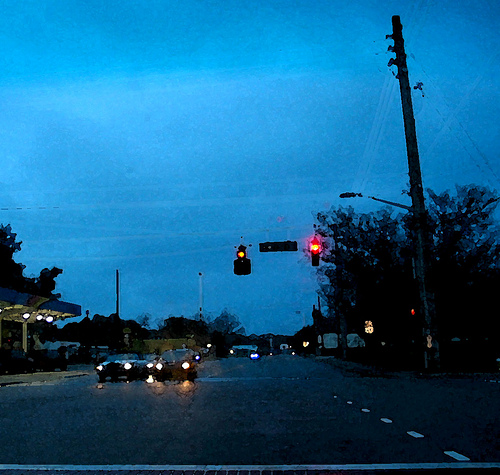Imagine what could be happening in the buildings and surroundings not visible directly. Beyond the immediate intersection scene, the buildings and surroundings could be buzzing with various activities. In one of the buildings, perhaps a cafe, people might be winding down after a long day, sipping on coffee and sharing stories. In another building, an office setting might witness the last few employees finishing up their day's work, while in the residential areas, families might be preparing dinner or settling in for a cozy evening at home. The trees, now dark silhouettes against the sky, might be sheltering small animals preparing for the night. Can you describe a creative story set in this scene? On an ordinary evening at this unremarkable intersection, something extraordinary begins to unfold. As the traffic light flickers briefly, almost ghostly, a soft hum fills the air. Unbeknownst to the drivers and passersby, this intersection has become a crossroads between dimensions. Each car passing through momentarily flickers between different versions of reality. In one version, a driver might find themselves in a parallel world where the city is populated by talking animals. In another, the sharegpt4v/same driver might encounter a futuristic cityscape dominated by towering skyscrapers and flying cars. The trees, too, might shift into fantastical forms—grand, sentient beings that watch over the city. The streetlights could morph into ancient guardians, silently observing these fleeting interdimensional travelers. The ordinary evening shrouds a hidden, magical phenomenon that connects worlds, witnessed only by those who look closely, but remembered by none. 